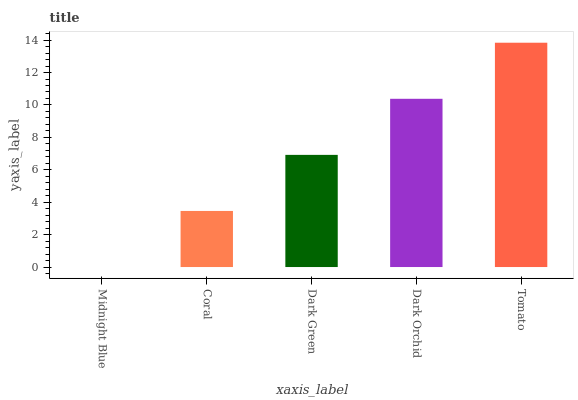Is Midnight Blue the minimum?
Answer yes or no. Yes. Is Tomato the maximum?
Answer yes or no. Yes. Is Coral the minimum?
Answer yes or no. No. Is Coral the maximum?
Answer yes or no. No. Is Coral greater than Midnight Blue?
Answer yes or no. Yes. Is Midnight Blue less than Coral?
Answer yes or no. Yes. Is Midnight Blue greater than Coral?
Answer yes or no. No. Is Coral less than Midnight Blue?
Answer yes or no. No. Is Dark Green the high median?
Answer yes or no. Yes. Is Dark Green the low median?
Answer yes or no. Yes. Is Midnight Blue the high median?
Answer yes or no. No. Is Coral the low median?
Answer yes or no. No. 